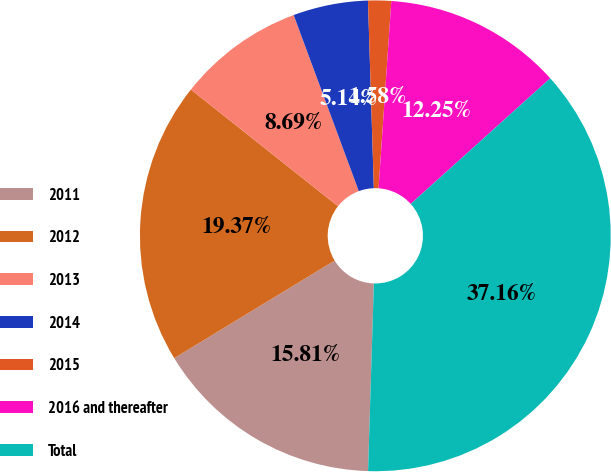<chart> <loc_0><loc_0><loc_500><loc_500><pie_chart><fcel>2011<fcel>2012<fcel>2013<fcel>2014<fcel>2015<fcel>2016 and thereafter<fcel>Total<nl><fcel>15.81%<fcel>19.37%<fcel>8.69%<fcel>5.14%<fcel>1.58%<fcel>12.25%<fcel>37.16%<nl></chart> 